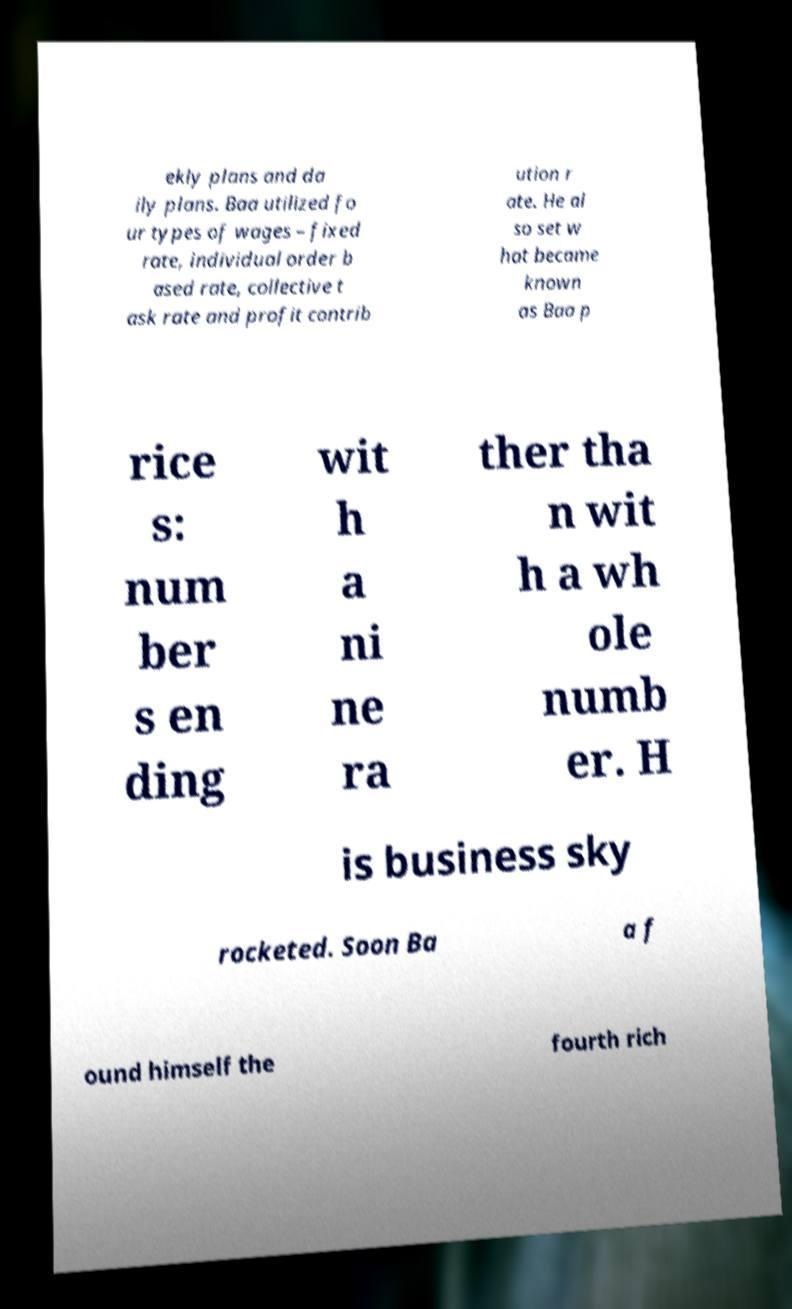For documentation purposes, I need the text within this image transcribed. Could you provide that? ekly plans and da ily plans. Baa utilized fo ur types of wages – fixed rate, individual order b ased rate, collective t ask rate and profit contrib ution r ate. He al so set w hat became known as Baa p rice s: num ber s en ding wit h a ni ne ra ther tha n wit h a wh ole numb er. H is business sky rocketed. Soon Ba a f ound himself the fourth rich 